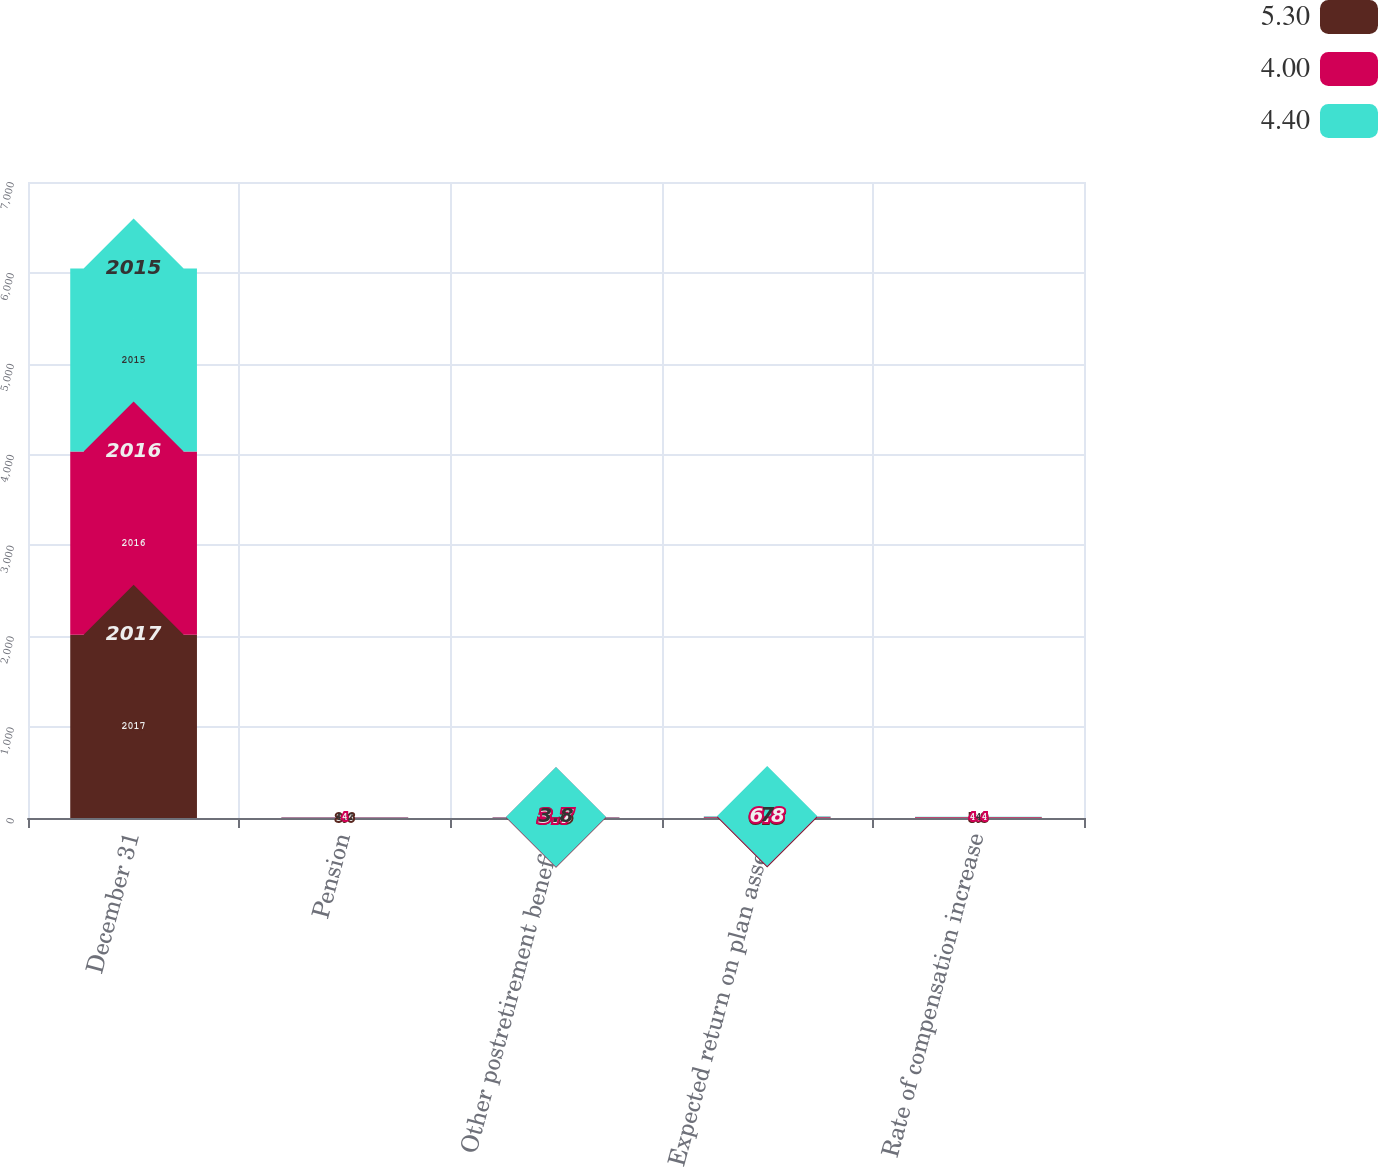Convert chart. <chart><loc_0><loc_0><loc_500><loc_500><stacked_bar_chart><ecel><fcel>December 31<fcel>Pension<fcel>Other postretirement benefits<fcel>Expected return on plan assets<fcel>Rate of compensation increase<nl><fcel>5.3<fcel>2017<fcel>3.6<fcel>3.3<fcel>6.8<fcel>5.3<nl><fcel>4<fcel>2016<fcel>4<fcel>3.7<fcel>6.8<fcel>4.4<nl><fcel>4.4<fcel>2015<fcel>4.2<fcel>3.8<fcel>7<fcel>4<nl></chart> 